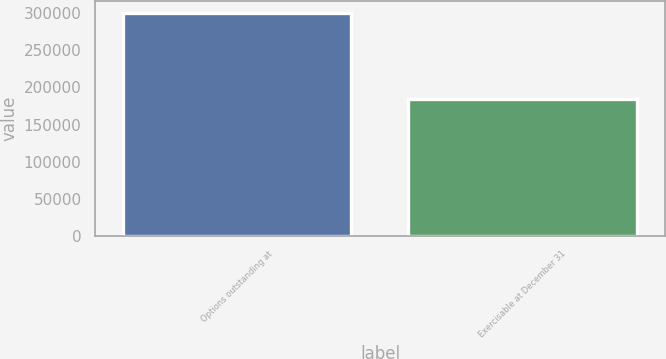Convert chart to OTSL. <chart><loc_0><loc_0><loc_500><loc_500><bar_chart><fcel>Options outstanding at<fcel>Exercisable at December 31<nl><fcel>300649<fcel>184019<nl></chart> 